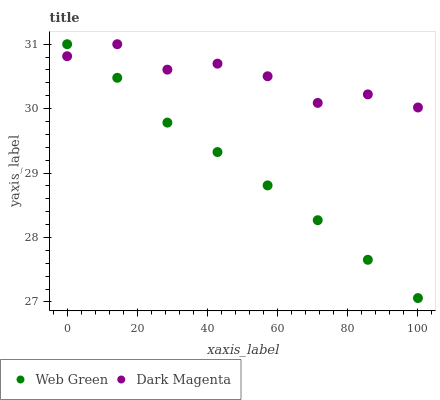Does Web Green have the minimum area under the curve?
Answer yes or no. Yes. Does Dark Magenta have the maximum area under the curve?
Answer yes or no. Yes. Does Web Green have the maximum area under the curve?
Answer yes or no. No. Is Web Green the smoothest?
Answer yes or no. Yes. Is Dark Magenta the roughest?
Answer yes or no. Yes. Is Web Green the roughest?
Answer yes or no. No. Does Web Green have the lowest value?
Answer yes or no. Yes. Does Web Green have the highest value?
Answer yes or no. Yes. Does Dark Magenta intersect Web Green?
Answer yes or no. Yes. Is Dark Magenta less than Web Green?
Answer yes or no. No. Is Dark Magenta greater than Web Green?
Answer yes or no. No. 